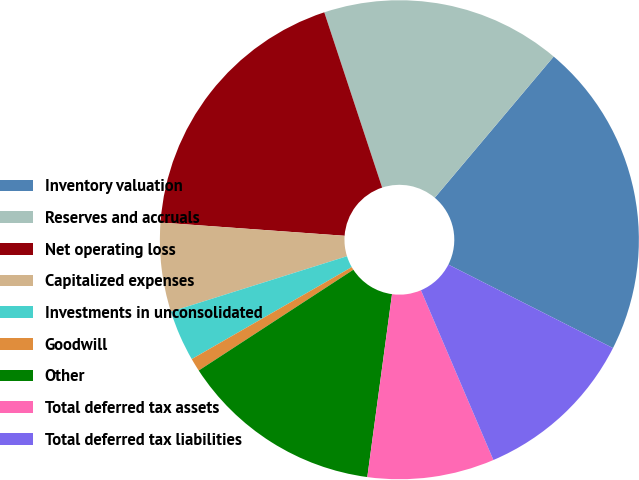Convert chart to OTSL. <chart><loc_0><loc_0><loc_500><loc_500><pie_chart><fcel>Inventory valuation<fcel>Reserves and accruals<fcel>Net operating loss<fcel>Capitalized expenses<fcel>Investments in unconsolidated<fcel>Goodwill<fcel>Other<fcel>Total deferred tax assets<fcel>Total deferred tax liabilities<nl><fcel>21.33%<fcel>16.22%<fcel>18.78%<fcel>6.0%<fcel>3.45%<fcel>0.89%<fcel>13.67%<fcel>8.56%<fcel>11.11%<nl></chart> 